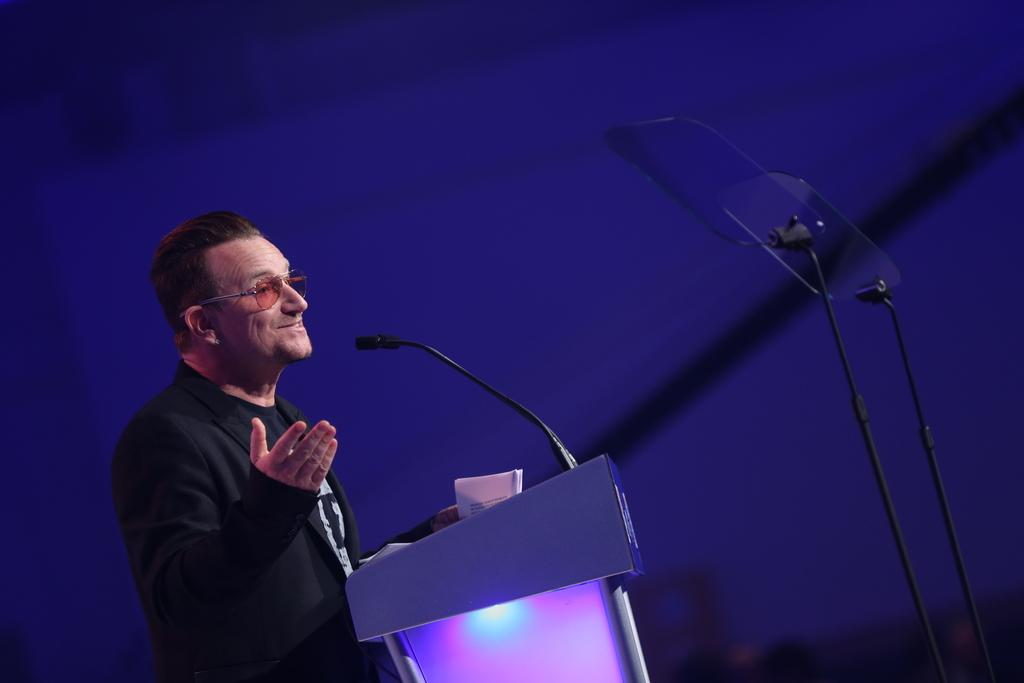What is the man in the image doing? The man is standing at a podium in the image. What is the man likely using to amplify his voice? There is a microphone in the image, which the man might be using to amplify his voice. What can be seen on the right side of the image? There are stands on the right side of the image. How would you describe the lighting in the image? The background of the image is dark. Can you see any wrens perched on the man's knee in the image? There are no wrens or any other birds visible in the image. 